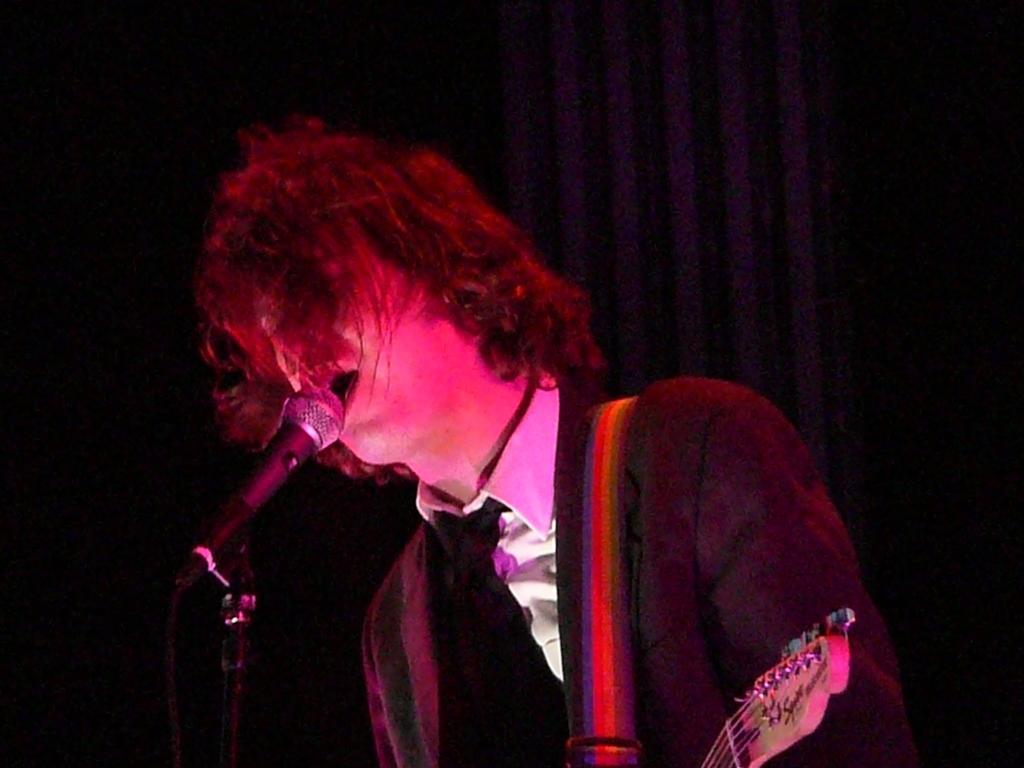Describe this image in one or two sentences. In this image a man wearing black coat, white shirt is singing. It seems like he is playing guitar. In front of him there is a mic. In the background there are curtains. 